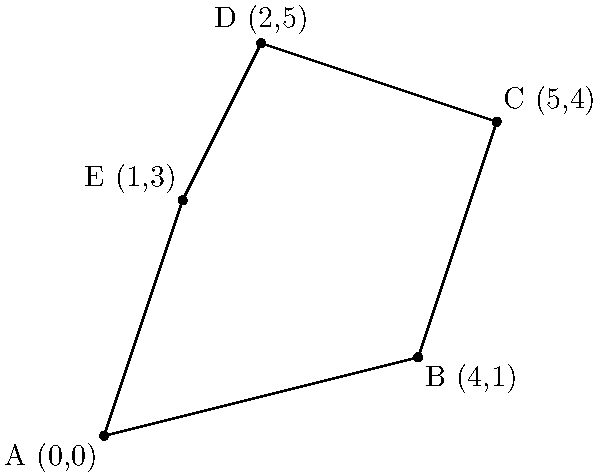In the latest season of Survivor, the production team has placed reward challenge sites at specific locations on the island. These locations form a polygon when connected on a coordinate grid, as shown in the diagram. The coordinates of the sites are A(0,0), B(4,1), C(5,4), D(2,5), and E(1,3). Calculate the area of the polygon formed by these challenge sites to determine the total area covered by the reward challenges this season. To calculate the area of the irregular polygon, we can use the Shoelace formula (also known as the surveyor's formula). The steps are as follows:

1) The Shoelace formula for a polygon with vertices $(x_1, y_1), (x_2, y_2), ..., (x_n, y_n)$ is:

   Area = $\frac{1}{2}|((x_1y_2 + x_2y_3 + ... + x_ny_1) - (y_1x_2 + y_2x_3 + ... + y_nx_1))|$

2) Let's organize our data:
   A(0,0), B(4,1), C(5,4), D(2,5), E(1,3)

3) Applying the formula:
   
   Area = $\frac{1}{2}|((0\cdot1 + 4\cdot4 + 5\cdot5 + 2\cdot3 + 1\cdot0) - (0\cdot4 + 1\cdot5 + 4\cdot2 + 5\cdot1 + 3\cdot0))|$

4) Simplify:
   
   Area = $\frac{1}{2}|((0 + 16 + 25 + 6 + 0) - (0 + 5 + 8 + 5 + 0))|$
   
   Area = $\frac{1}{2}|(47 - 18)|$
   
   Area = $\frac{1}{2}(29)$
   
   Area = 14.5

Therefore, the area of the polygon formed by the reward challenge sites is 14.5 square units.
Answer: 14.5 square units 